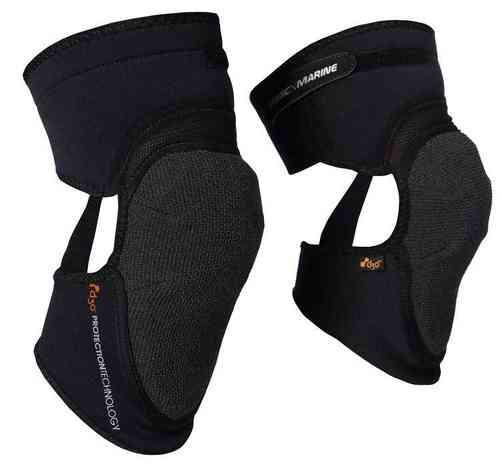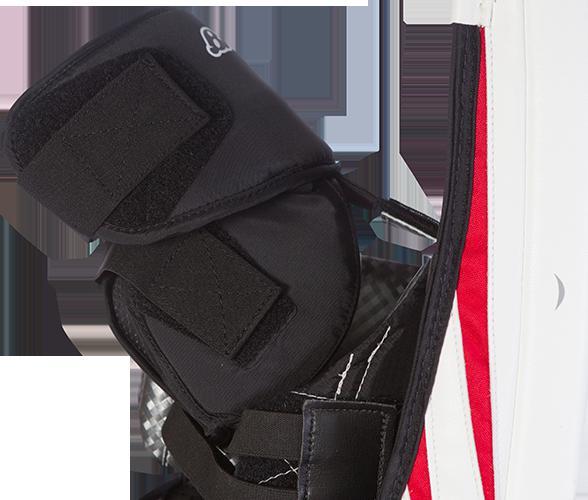The first image is the image on the left, the second image is the image on the right. Evaluate the accuracy of this statement regarding the images: "The two black knee pads face opposite directions.". Is it true? Answer yes or no. No. 